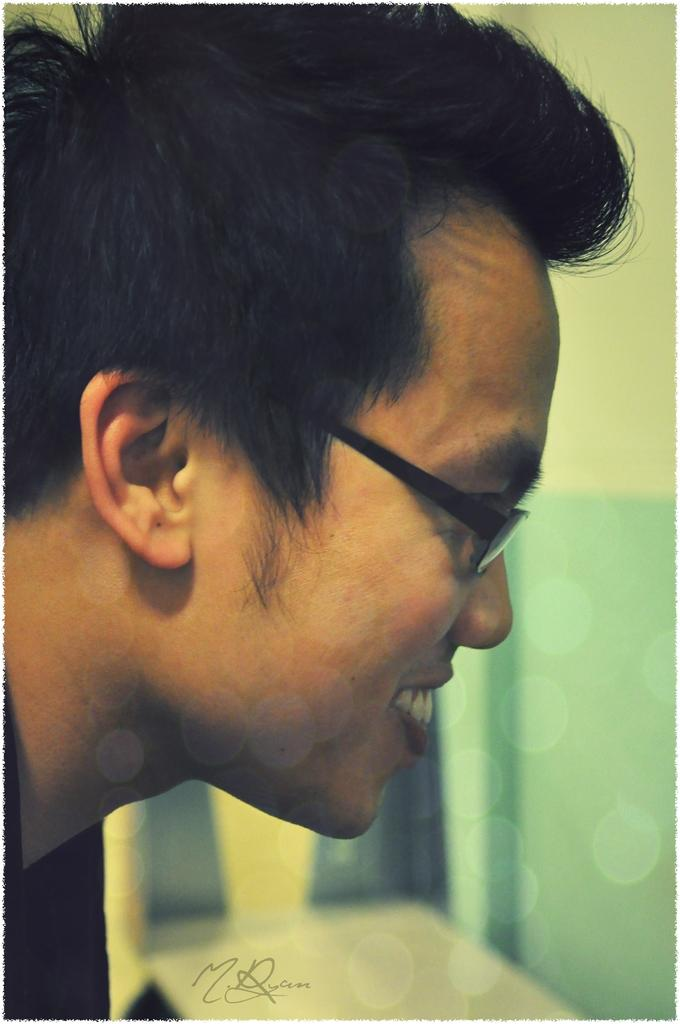What is the main subject of the image? There is a person in the image. What can be seen in the background of the image? There is a wall in the background of the image. Is there any text present in the image? Yes, there is some text at the bottom of the image. How many cherries are hanging from the person's ear in the image? There are no cherries present in the image, so it is not possible to determine how many might be hanging from the person's ear. 